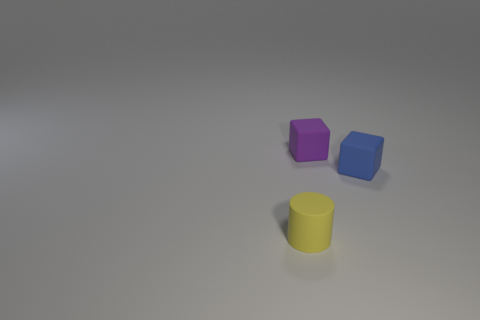What number of objects are small blue blocks or small things that are right of the tiny purple matte cube?
Your answer should be very brief. 1. How many blocks are tiny blue objects or small objects?
Provide a succinct answer. 2. What number of small things are both in front of the blue matte cube and to the right of the yellow matte cylinder?
Offer a very short reply. 0. There is a small matte object that is left of the purple cube; what is its shape?
Give a very brief answer. Cylinder. Do the tiny blue thing and the small cylinder have the same material?
Give a very brief answer. Yes. Is there anything else that has the same size as the yellow object?
Offer a very short reply. Yes. There is a tiny purple rubber object; how many tiny cubes are on the right side of it?
Your response must be concise. 1. What is the shape of the small object behind the small cube to the right of the purple rubber cube?
Give a very brief answer. Cube. Are there any other things that are the same shape as the tiny yellow matte thing?
Make the answer very short. No. Are there more small cubes on the right side of the blue rubber object than small blue objects?
Your answer should be very brief. No. 